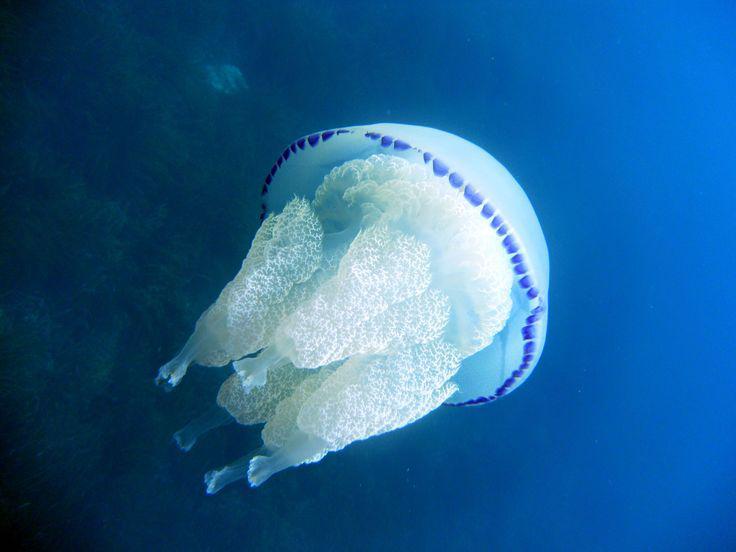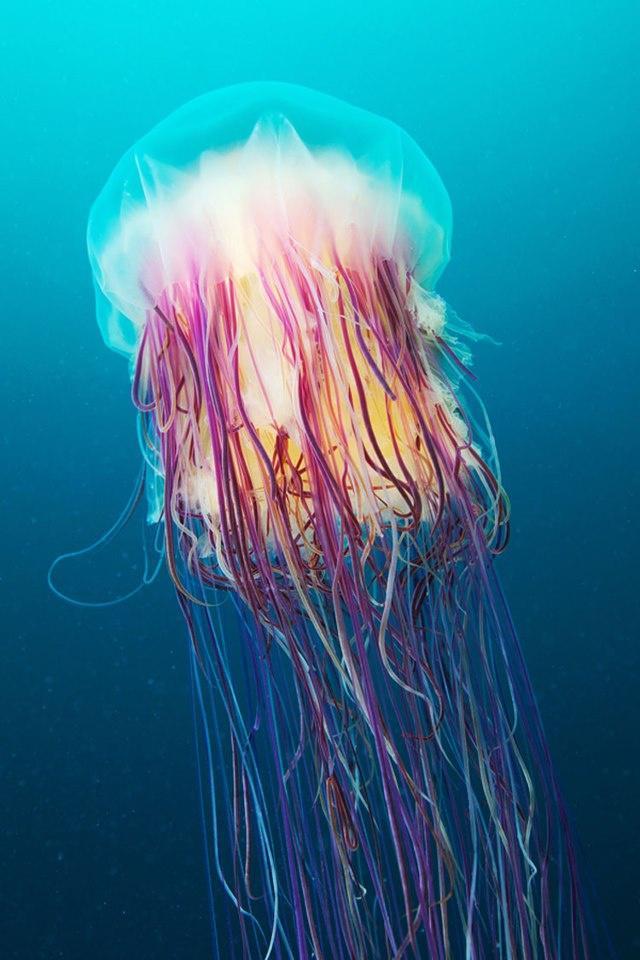The first image is the image on the left, the second image is the image on the right. Given the left and right images, does the statement "The jellyfish on the right is yellowish, with a rounded top and a cauliflower-like bottom without long tendrils." hold true? Answer yes or no. No. The first image is the image on the left, the second image is the image on the right. For the images shown, is this caption "At least one jellyfish has long, stringy tentacles." true? Answer yes or no. Yes. 